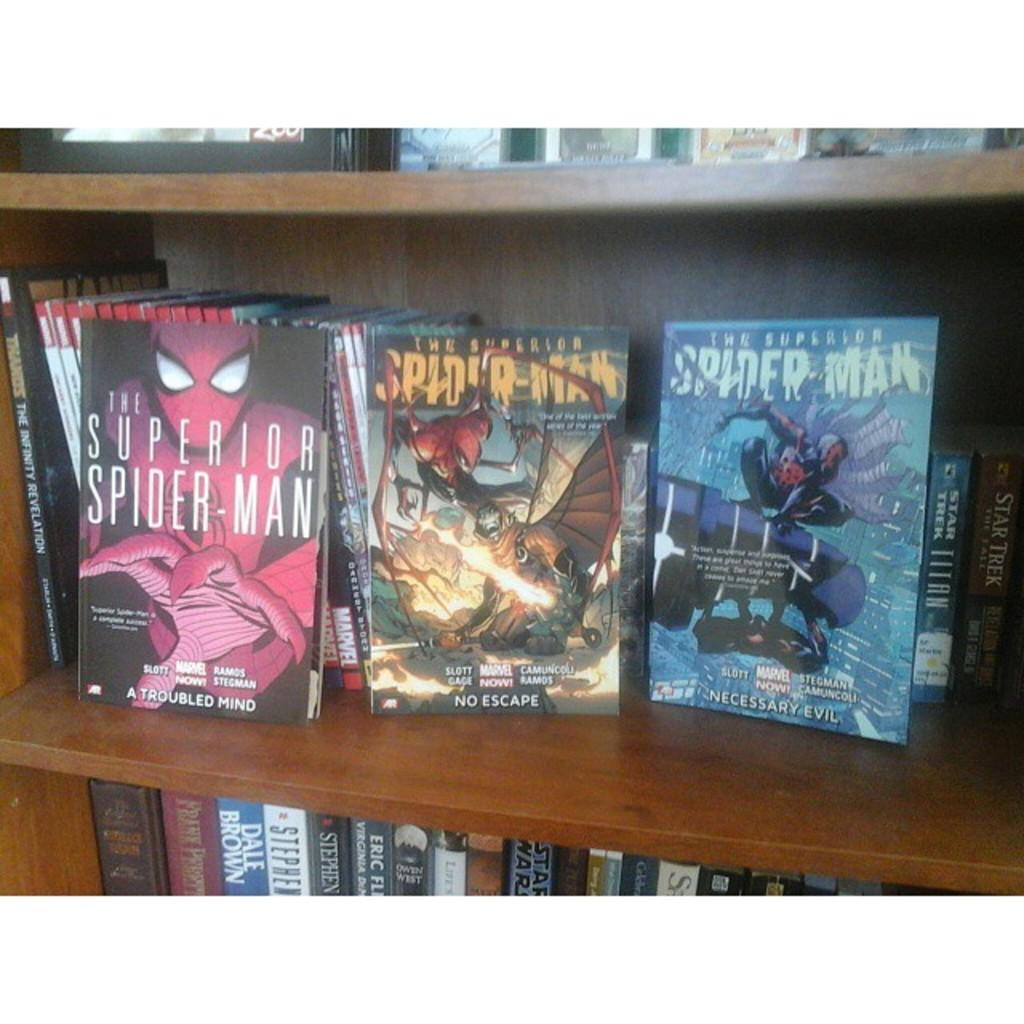What is the main object in the image? There is a rack in the image. What is stored on the rack? The rack contains books. How many clovers can be seen growing on the rack in the image? There are no clovers present in the image; the rack contains books. 